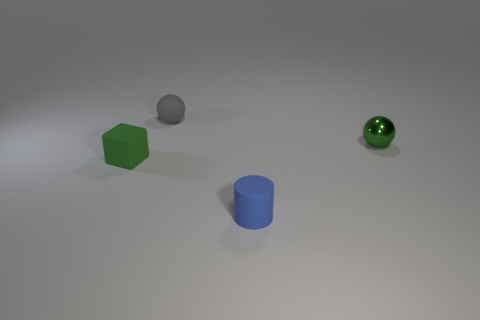There is a gray thing that is the same shape as the green shiny thing; what size is it?
Your answer should be very brief. Small. There is a rubber thing that is both on the right side of the tiny green matte cube and behind the tiny blue rubber cylinder; how big is it?
Offer a terse response. Small. There is a tiny rubber object that is the same color as the small shiny thing; what shape is it?
Give a very brief answer. Cube. The tiny rubber cylinder is what color?
Provide a succinct answer. Blue. What size is the green object that is on the left side of the rubber sphere?
Make the answer very short. Small. There is a matte thing to the left of the small rubber thing that is behind the small green rubber object; what number of rubber balls are to the right of it?
Your answer should be compact. 1. What is the color of the small sphere that is right of the ball on the left side of the cylinder?
Give a very brief answer. Green. Is there a matte object that has the same size as the blue cylinder?
Provide a short and direct response. Yes. The tiny object to the right of the tiny matte cylinder that is in front of the small ball that is on the left side of the tiny metallic sphere is made of what material?
Provide a short and direct response. Metal. There is a green object in front of the green metal ball; how many green shiny balls are left of it?
Offer a terse response. 0. 